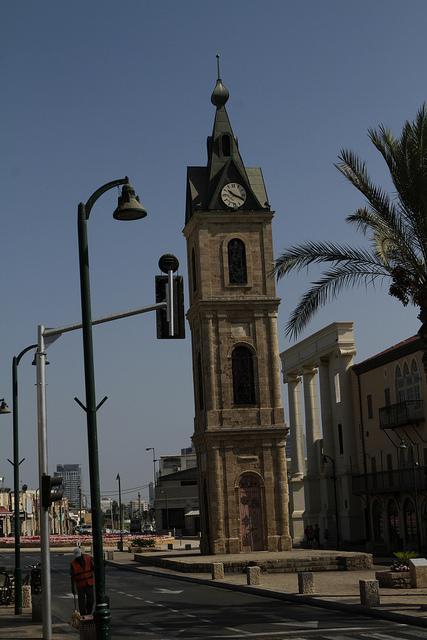How many clock faces are on the tower?
Give a very brief answer. 1. How many lights are on the light post?
Give a very brief answer. 1. How many chimneys are there?
Give a very brief answer. 0. How many windows are on the side of the building?
Give a very brief answer. 3. How many clouds are in the sky?
Give a very brief answer. 0. How many towers are there?
Give a very brief answer. 1. 